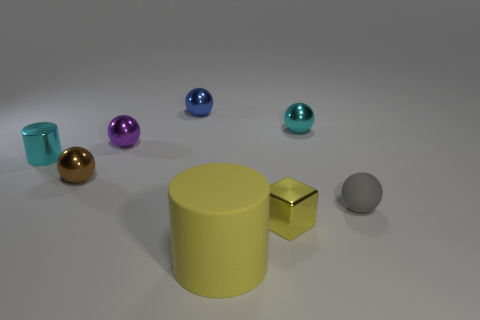Subtract all brown spheres. How many spheres are left? 4 Subtract all purple metallic spheres. How many spheres are left? 4 Subtract all yellow balls. Subtract all red cylinders. How many balls are left? 5 Add 1 cylinders. How many objects exist? 9 Subtract all cylinders. How many objects are left? 6 Add 3 brown metallic things. How many brown metallic things exist? 4 Subtract 0 purple cylinders. How many objects are left? 8 Subtract all tiny yellow objects. Subtract all small gray rubber things. How many objects are left? 6 Add 3 tiny purple balls. How many tiny purple balls are left? 4 